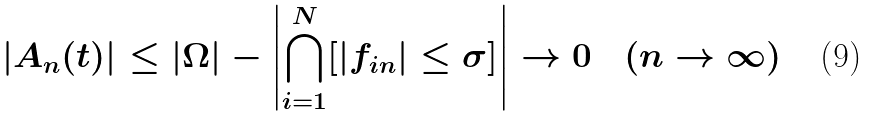<formula> <loc_0><loc_0><loc_500><loc_500>| A _ { n } ( t ) | \leq | \Omega | - \left | \bigcap _ { i = 1 } ^ { N } [ | f _ { i n } | \leq \sigma ] \right | \to 0 \quad ( n \to \infty )</formula> 